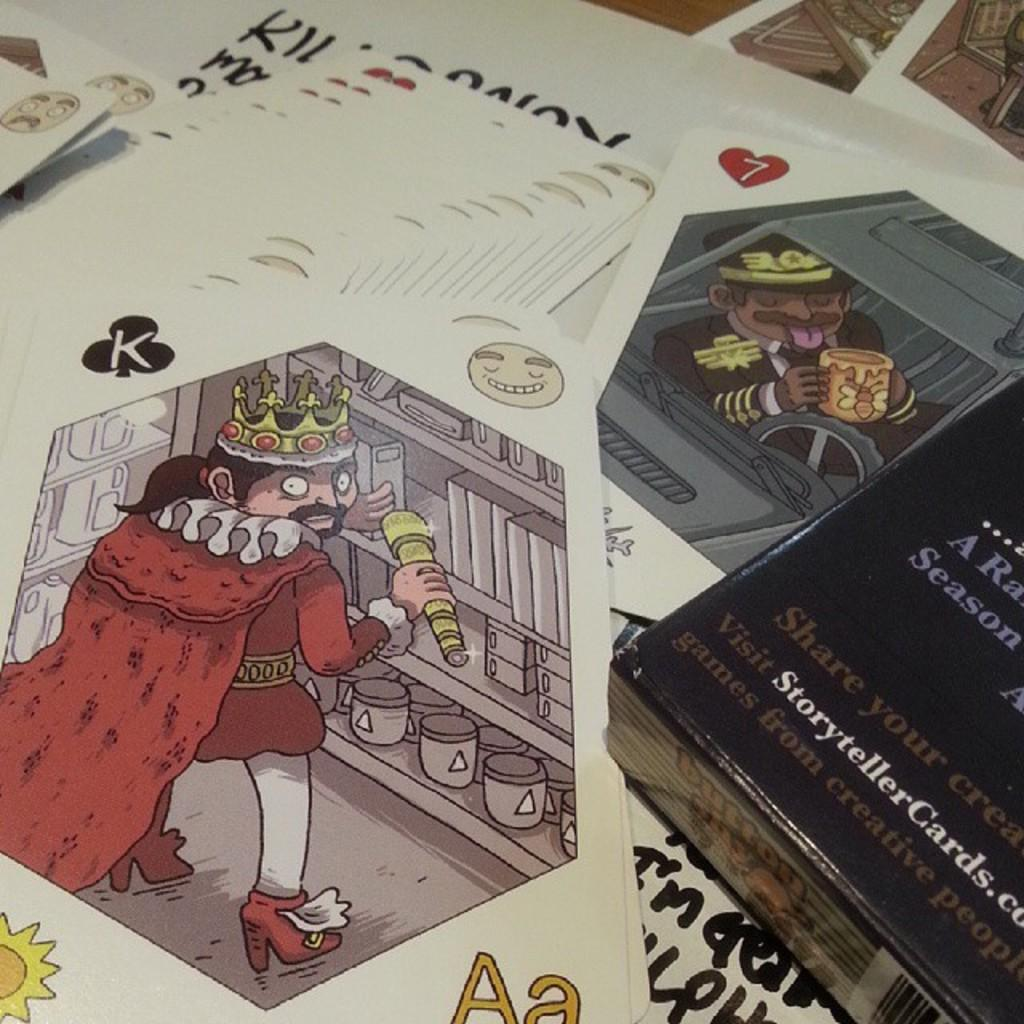Provide a one-sentence caption for the provided image. Fortune cards are sitting in a pile next to a black book that says visit storytellercards.com. 